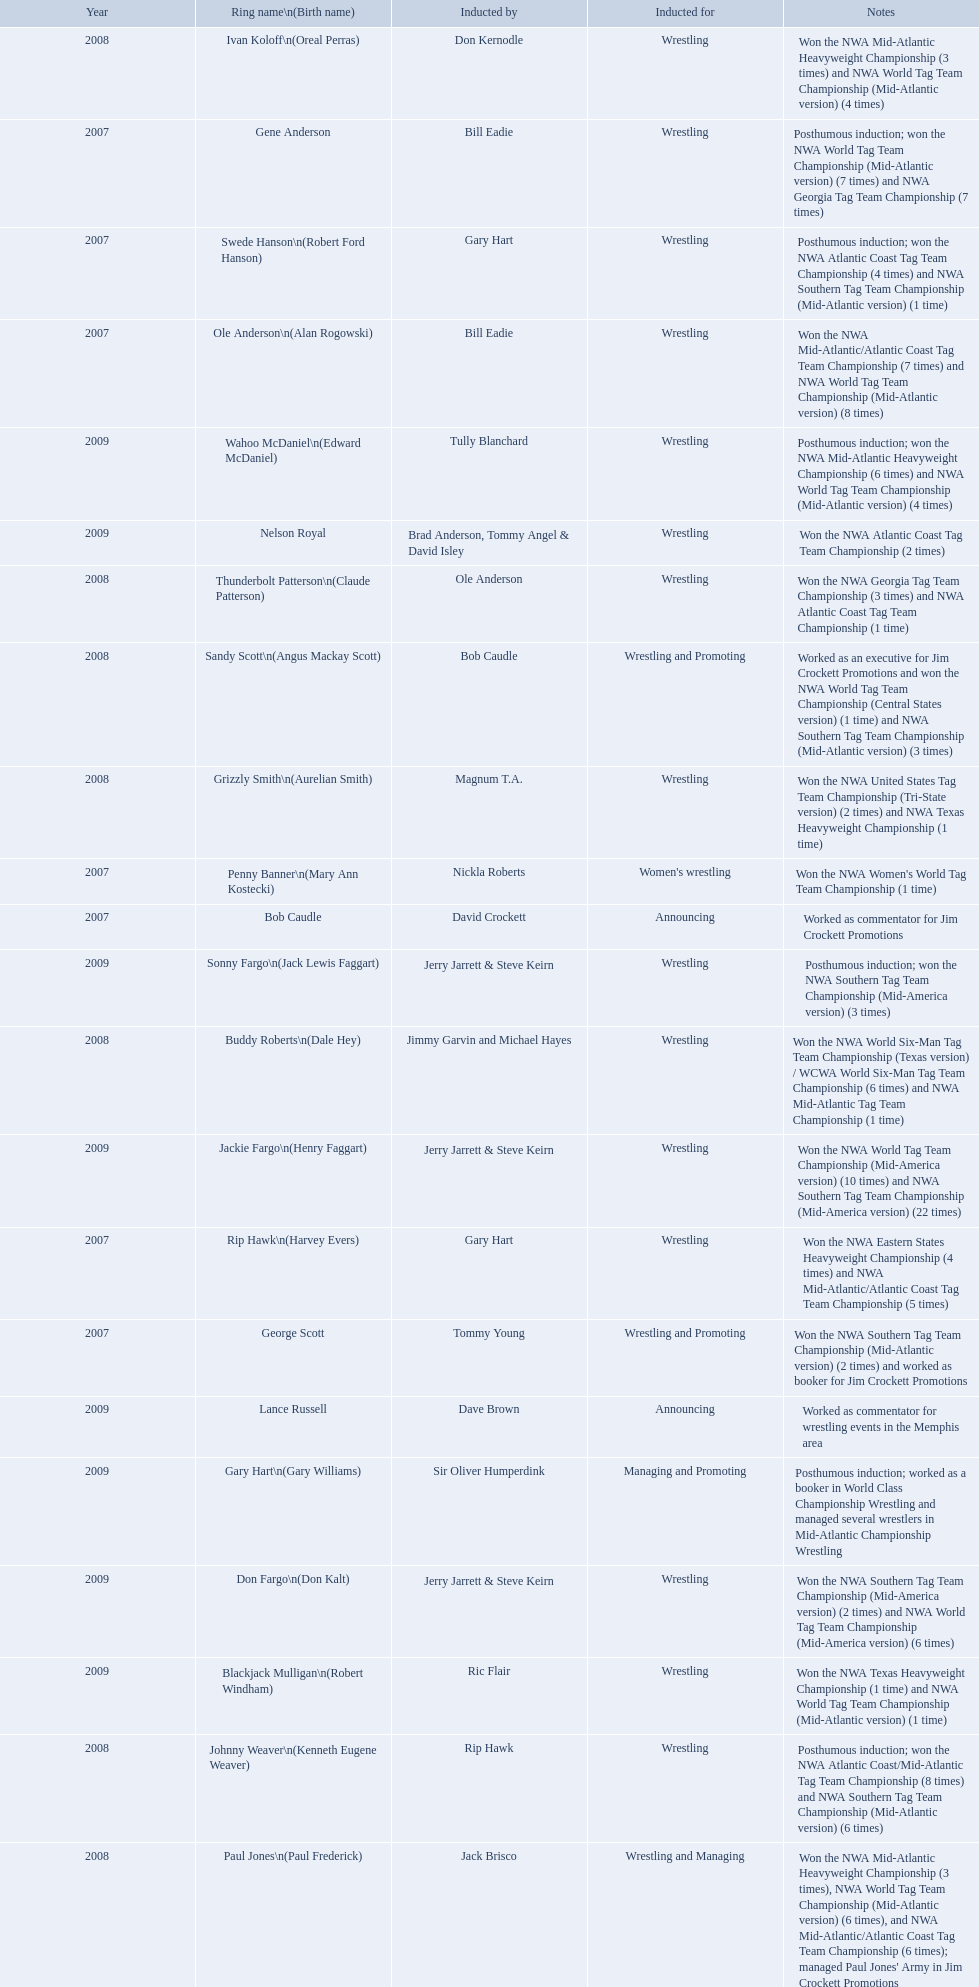What were all the wrestler's ring names? Gene Anderson, Ole Anderson\n(Alan Rogowski), Penny Banner\n(Mary Ann Kostecki), Bob Caudle, Swede Hanson\n(Robert Ford Hanson), Rip Hawk\n(Harvey Evers), George Scott, Paul Jones\n(Paul Frederick), Ivan Koloff\n(Oreal Perras), Thunderbolt Patterson\n(Claude Patterson), Buddy Roberts\n(Dale Hey), Sandy Scott\n(Angus Mackay Scott), Grizzly Smith\n(Aurelian Smith), Johnny Weaver\n(Kenneth Eugene Weaver), Don Fargo\n(Don Kalt), Jackie Fargo\n(Henry Faggart), Sonny Fargo\n(Jack Lewis Faggart), Gary Hart\n(Gary Williams), Wahoo McDaniel\n(Edward McDaniel), Blackjack Mulligan\n(Robert Windham), Nelson Royal, Lance Russell. Besides bob caudle, who was an announcer? Lance Russell. 